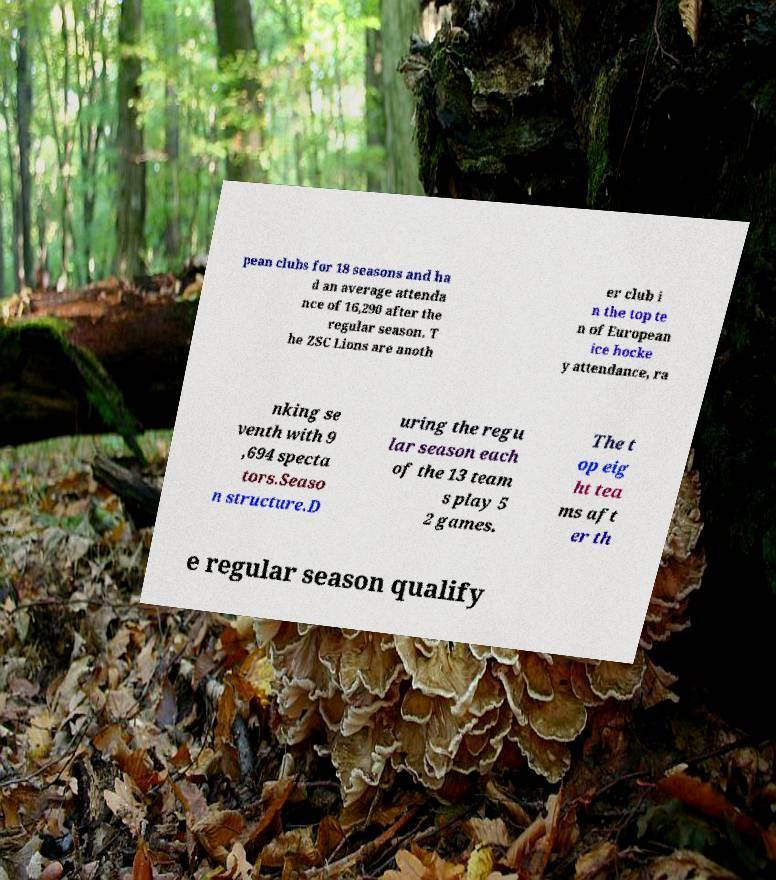Please identify and transcribe the text found in this image. pean clubs for 18 seasons and ha d an average attenda nce of 16,290 after the regular season. T he ZSC Lions are anoth er club i n the top te n of European ice hocke y attendance, ra nking se venth with 9 ,694 specta tors.Seaso n structure.D uring the regu lar season each of the 13 team s play 5 2 games. The t op eig ht tea ms aft er th e regular season qualify 